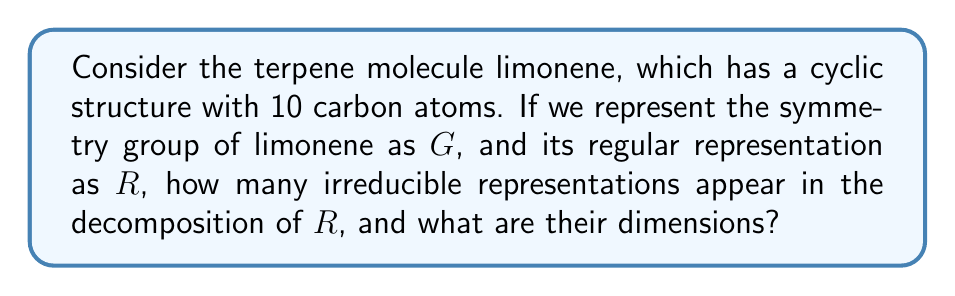Give your solution to this math problem. To solve this problem, let's follow these steps:

1) First, we need to identify the symmetry group of limonene. Limonene has a C2 axis and a mirror plane, which corresponds to the C2v point group.

2) The C2v group has 4 irreducible representations: A1, A2, B1, and B2. All of these are 1-dimensional.

3) The regular representation $R$ of a group $G$ always decomposes into a direct sum of all irreducible representations, with each appearing a number of times equal to its dimension.

4) The dimension of the regular representation is equal to the order of the group. For C2v, the order is 4.

5) Therefore, the decomposition of $R$ for C2v is:

   $$R = A1 \oplus A2 \oplus B1 \oplus B2$$

6) Each irreducible representation appears exactly once because they are all 1-dimensional.

7) To count the number of irreducible representations, we simply count the terms in this decomposition, which is 4.

8) The dimensions of these representations are all 1.
Answer: 4 irreducible representations, each of dimension 1 